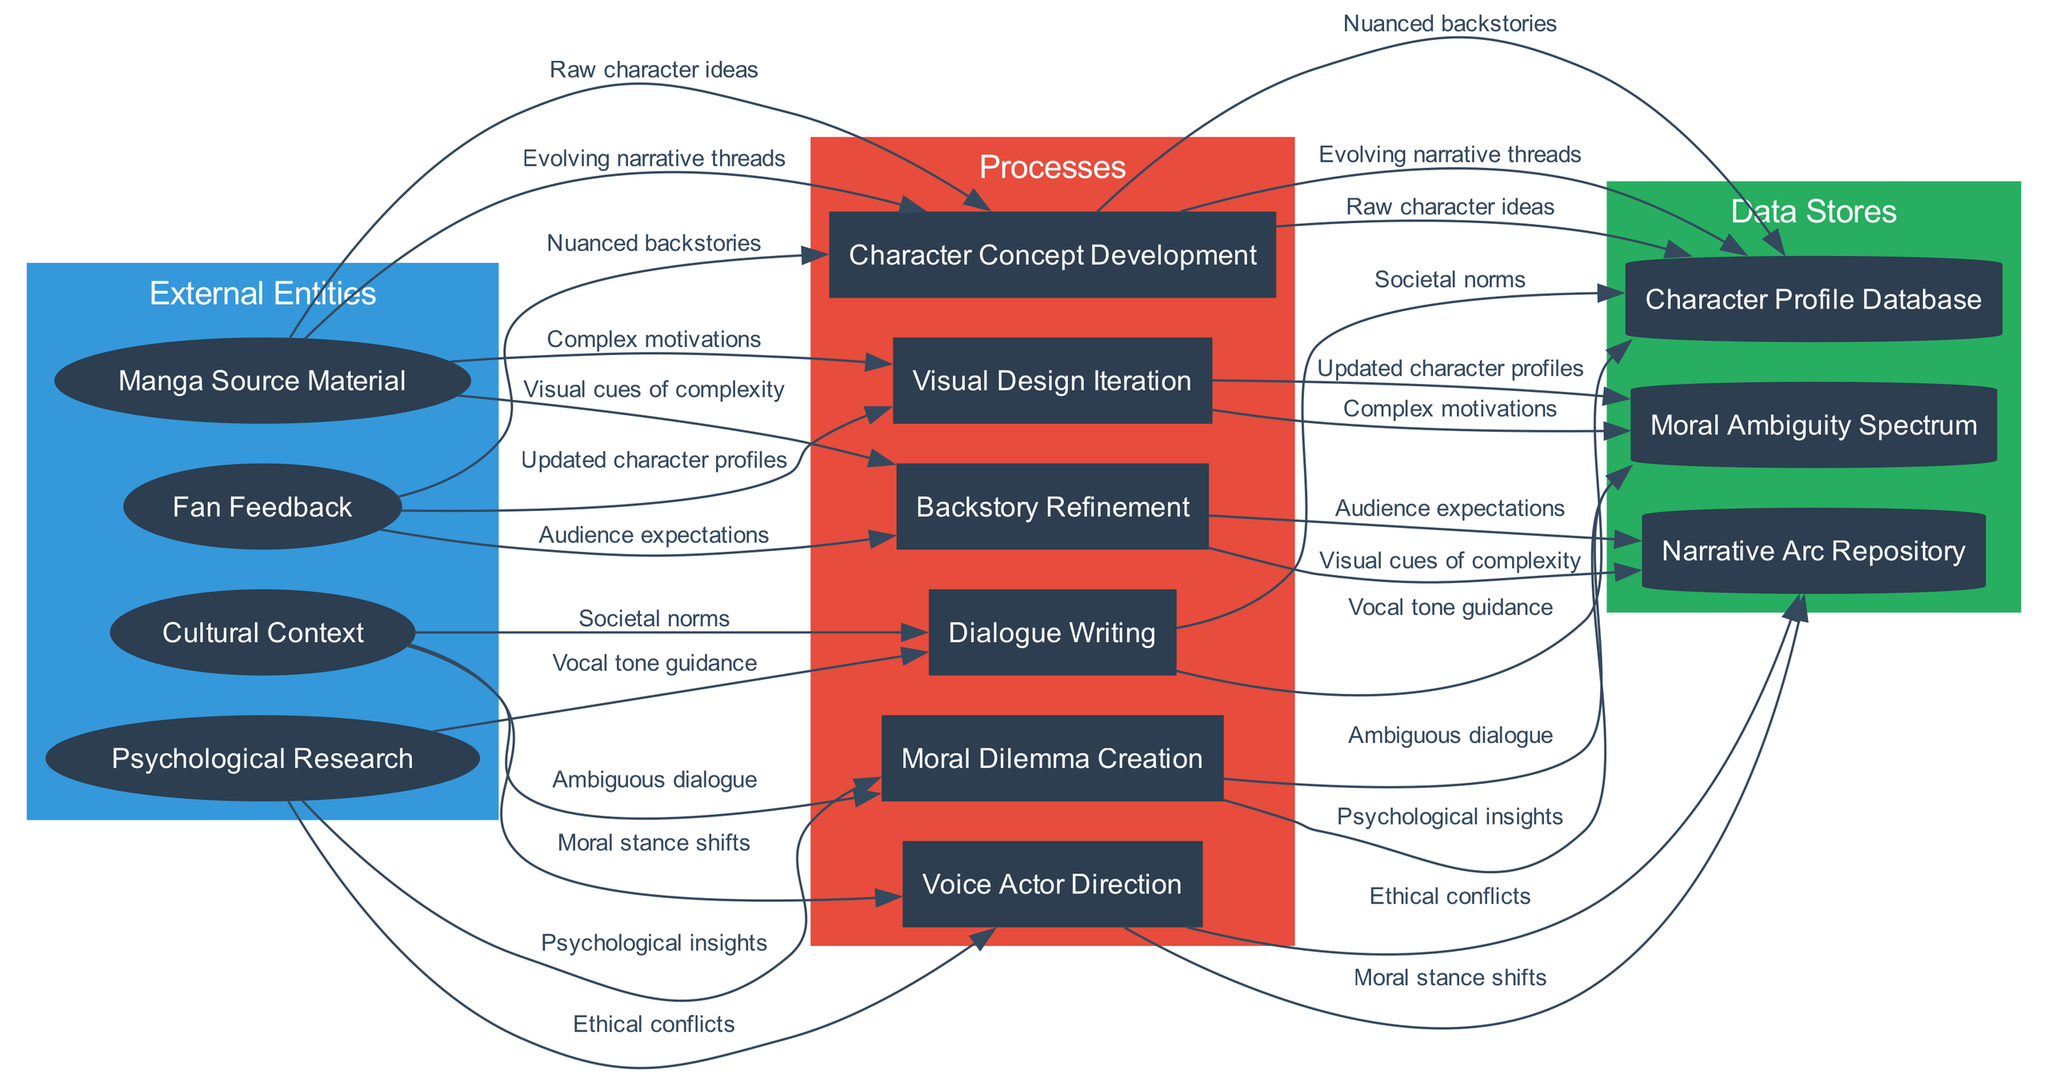What are the external entities in the diagram? The external entities listed in the diagram include the Manga Source Material, Psychological Research, Fan Feedback, and Cultural Context.
Answer: Manga Source Material, Psychological Research, Fan Feedback, Cultural Context How many processes are there? The diagram depicts a total of six processes related to character development. These processes are Character Concept Development, Moral Dilemma Creation, Backstory Refinement, Dialogue Writing, Visual Design Iteration, and Voice Actor Direction.
Answer: Six What does the 'Moral Dilemma Creation' process yield as an output? The 'Moral Dilemma Creation' process interacts with the Moral Ambiguity Spectrum data store, and outputs Ethical conflicts and Complex motivations which are represented as data flows accordingly.
Answer: Ethical conflicts, Complex motivations Which data store contains nuanced backstories? The nuanced backstories are stored in the Character Profile Database according to the flow from the Backstory Refinement process.
Answer: Character Profile Database From how many external entities does the process 'Dialogue Writing' receive inputs? The process 'Dialogue Writing' receives inputs from all four external entities, representing the complex relationship between external feedback and the anime character's dialogues.
Answer: Four What is the relationship between Moral Ambiguity Spectrum and Character Concept Development? The Moral Ambiguity Spectrum provides inputs of psychological insights and audience expectations to the Character Concept Development process, indicating its influence in character design from a moral perspective.
Answer: Psychological insights, Audience expectations Which process handles Visual cues of complexity? The Visual Design Iteration process directly receives Visual cues of complexity from various flows, shaping the character's visual representation to match its moral ambiguity.
Answer: Visual Design Iteration How many data flows are connected to the Voice Actor Direction process? The Voice Actor Direction process is connected to two data flows: Vocal tone guidance and Nuanced backstories, indicating the importance of voice in conveying complex character emotions.
Answer: Two What type of design does the process 'Visual Design Iteration' focus on? The Visual Design Iteration process focuses on the visual representation and cues that communicate the character's moral ambiguity visually to the audience.
Answer: Visual cues of complexity 